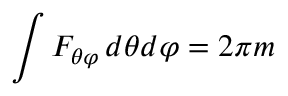<formula> <loc_0><loc_0><loc_500><loc_500>\int F _ { \theta \varphi } \, d \theta d \varphi = 2 \pi m</formula> 